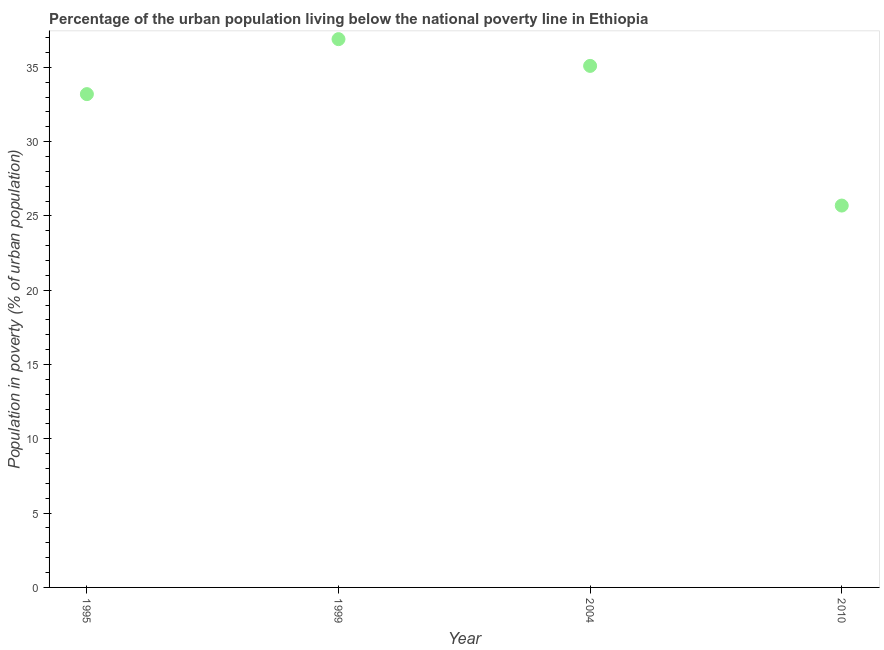What is the percentage of urban population living below poverty line in 1999?
Your answer should be very brief. 36.9. Across all years, what is the maximum percentage of urban population living below poverty line?
Your response must be concise. 36.9. Across all years, what is the minimum percentage of urban population living below poverty line?
Ensure brevity in your answer.  25.7. In which year was the percentage of urban population living below poverty line maximum?
Give a very brief answer. 1999. What is the sum of the percentage of urban population living below poverty line?
Offer a terse response. 130.9. What is the difference between the percentage of urban population living below poverty line in 2004 and 2010?
Your answer should be very brief. 9.4. What is the average percentage of urban population living below poverty line per year?
Your answer should be compact. 32.72. What is the median percentage of urban population living below poverty line?
Your answer should be very brief. 34.15. What is the ratio of the percentage of urban population living below poverty line in 1995 to that in 1999?
Give a very brief answer. 0.9. What is the difference between the highest and the second highest percentage of urban population living below poverty line?
Give a very brief answer. 1.8. Does the percentage of urban population living below poverty line monotonically increase over the years?
Your answer should be compact. No. How many dotlines are there?
Your answer should be very brief. 1. What is the difference between two consecutive major ticks on the Y-axis?
Give a very brief answer. 5. What is the title of the graph?
Provide a short and direct response. Percentage of the urban population living below the national poverty line in Ethiopia. What is the label or title of the Y-axis?
Provide a short and direct response. Population in poverty (% of urban population). What is the Population in poverty (% of urban population) in 1995?
Offer a very short reply. 33.2. What is the Population in poverty (% of urban population) in 1999?
Offer a terse response. 36.9. What is the Population in poverty (% of urban population) in 2004?
Your response must be concise. 35.1. What is the Population in poverty (% of urban population) in 2010?
Make the answer very short. 25.7. What is the difference between the Population in poverty (% of urban population) in 1995 and 1999?
Provide a succinct answer. -3.7. What is the difference between the Population in poverty (% of urban population) in 1995 and 2004?
Offer a very short reply. -1.9. What is the difference between the Population in poverty (% of urban population) in 1995 and 2010?
Ensure brevity in your answer.  7.5. What is the difference between the Population in poverty (% of urban population) in 2004 and 2010?
Your answer should be very brief. 9.4. What is the ratio of the Population in poverty (% of urban population) in 1995 to that in 2004?
Ensure brevity in your answer.  0.95. What is the ratio of the Population in poverty (% of urban population) in 1995 to that in 2010?
Your answer should be compact. 1.29. What is the ratio of the Population in poverty (% of urban population) in 1999 to that in 2004?
Keep it short and to the point. 1.05. What is the ratio of the Population in poverty (% of urban population) in 1999 to that in 2010?
Your answer should be very brief. 1.44. What is the ratio of the Population in poverty (% of urban population) in 2004 to that in 2010?
Ensure brevity in your answer.  1.37. 